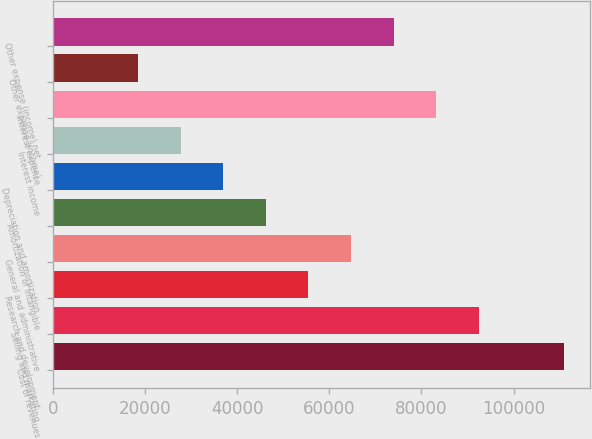<chart> <loc_0><loc_0><loc_500><loc_500><bar_chart><fcel>Cost of revenues<fcel>Selling and marketing<fcel>Research and development<fcel>General and administrative<fcel>Amortization of intangible<fcel>Depreciation and amortization<fcel>Interest income<fcel>Interest expense<fcel>Other expense (income)<fcel>Other expense (income) net<nl><fcel>110960<fcel>92467<fcel>55480.5<fcel>64727.1<fcel>46233.8<fcel>36987.2<fcel>27740.6<fcel>83220.4<fcel>18494<fcel>73973.7<nl></chart> 